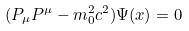<formula> <loc_0><loc_0><loc_500><loc_500>( P _ { \mu } P ^ { \mu } - m _ { 0 } ^ { 2 } c ^ { 2 } ) \Psi ( x ) = 0</formula> 